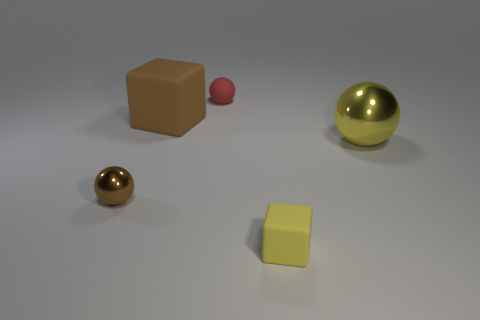Add 3 things. How many objects exist? 8 Subtract all spheres. How many objects are left? 2 Add 3 tiny red rubber objects. How many tiny red rubber objects exist? 4 Subtract 0 purple cylinders. How many objects are left? 5 Subtract all yellow rubber things. Subtract all yellow rubber blocks. How many objects are left? 3 Add 2 yellow metal balls. How many yellow metal balls are left? 3 